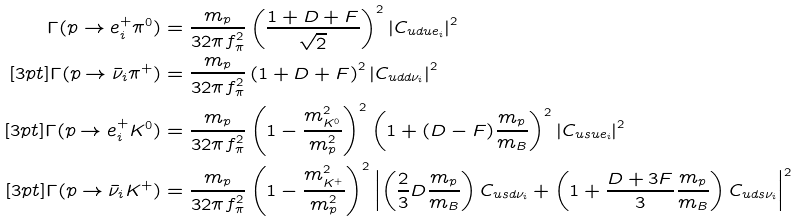Convert formula to latex. <formula><loc_0><loc_0><loc_500><loc_500>\Gamma ( p \to e _ { i } ^ { + } \pi ^ { 0 } ) & = \frac { m _ { p } } { 3 2 \pi f _ { \pi } ^ { 2 } } \left ( \frac { 1 + D + F } { \sqrt { 2 } } \right ) ^ { 2 } \left | C _ { u d u e _ { i } } \right | ^ { 2 } \\ [ 3 p t ] \Gamma ( p \to \bar { \nu } _ { i } \pi ^ { + } ) & = \frac { m _ { p } } { 3 2 \pi f _ { \pi } ^ { 2 } } \left ( 1 + D + F \right ) ^ { 2 } \left | C _ { u d d \nu _ { i } } \right | ^ { 2 } \\ [ 3 p t ] \Gamma ( p \to e _ { i } ^ { + } K ^ { 0 } ) & = \frac { m _ { p } } { 3 2 \pi f _ { \pi } ^ { 2 } } \left ( 1 - \frac { m _ { K ^ { 0 } } ^ { 2 } } { m _ { p } ^ { 2 } } \right ) ^ { 2 } \left ( 1 + ( D - F ) \frac { m _ { p } } { m _ { B } } \right ) ^ { 2 } \left | C _ { u s u e _ { i } } \right | ^ { 2 } \\ [ 3 p t ] \Gamma ( p \to \bar { \nu } _ { i } K ^ { + } ) & = \frac { m _ { p } } { 3 2 \pi f _ { \pi } ^ { 2 } } \left ( 1 - \frac { m _ { K ^ { + } } ^ { 2 } } { m _ { p } ^ { 2 } } \right ) ^ { 2 } \left | \left ( \frac { 2 } { 3 } D \frac { m _ { p } } { m _ { B } } \right ) C _ { u s d \nu _ { i } } + \left ( 1 + \frac { D + 3 F } { 3 } \frac { m _ { p } } { m _ { B } } \right ) C _ { u d s \nu _ { i } } \right | ^ { 2 }</formula> 